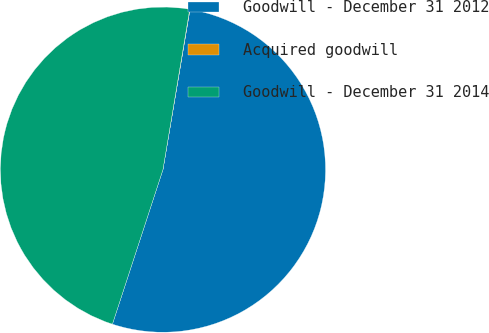Convert chart to OTSL. <chart><loc_0><loc_0><loc_500><loc_500><pie_chart><fcel>Goodwill - December 31 2012<fcel>Acquired goodwill<fcel>Goodwill - December 31 2014<nl><fcel>52.37%<fcel>0.03%<fcel>47.61%<nl></chart> 